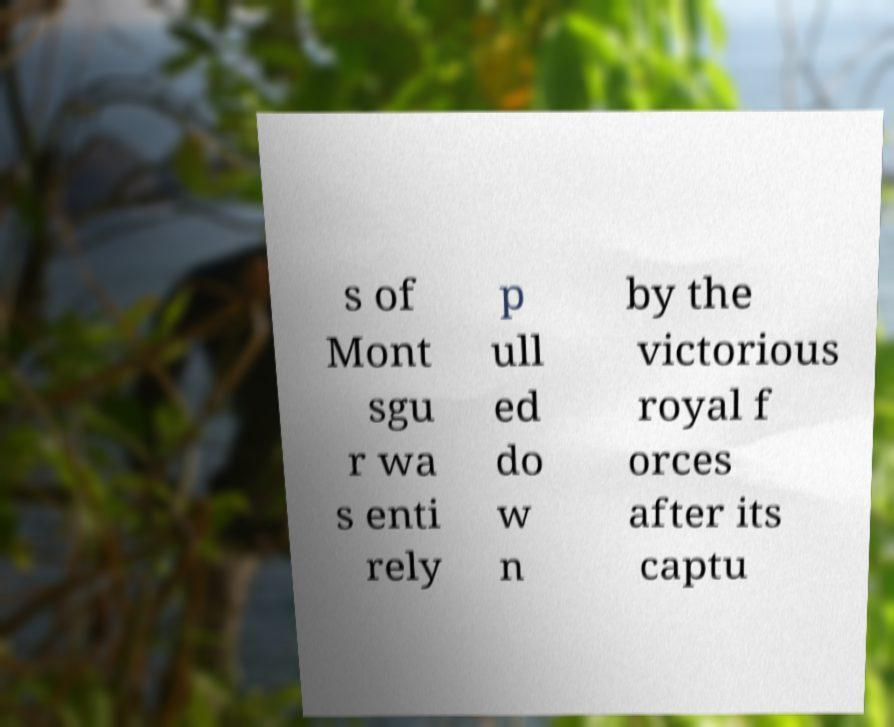Please read and relay the text visible in this image. What does it say? s of Mont sgu r wa s enti rely p ull ed do w n by the victorious royal f orces after its captu 